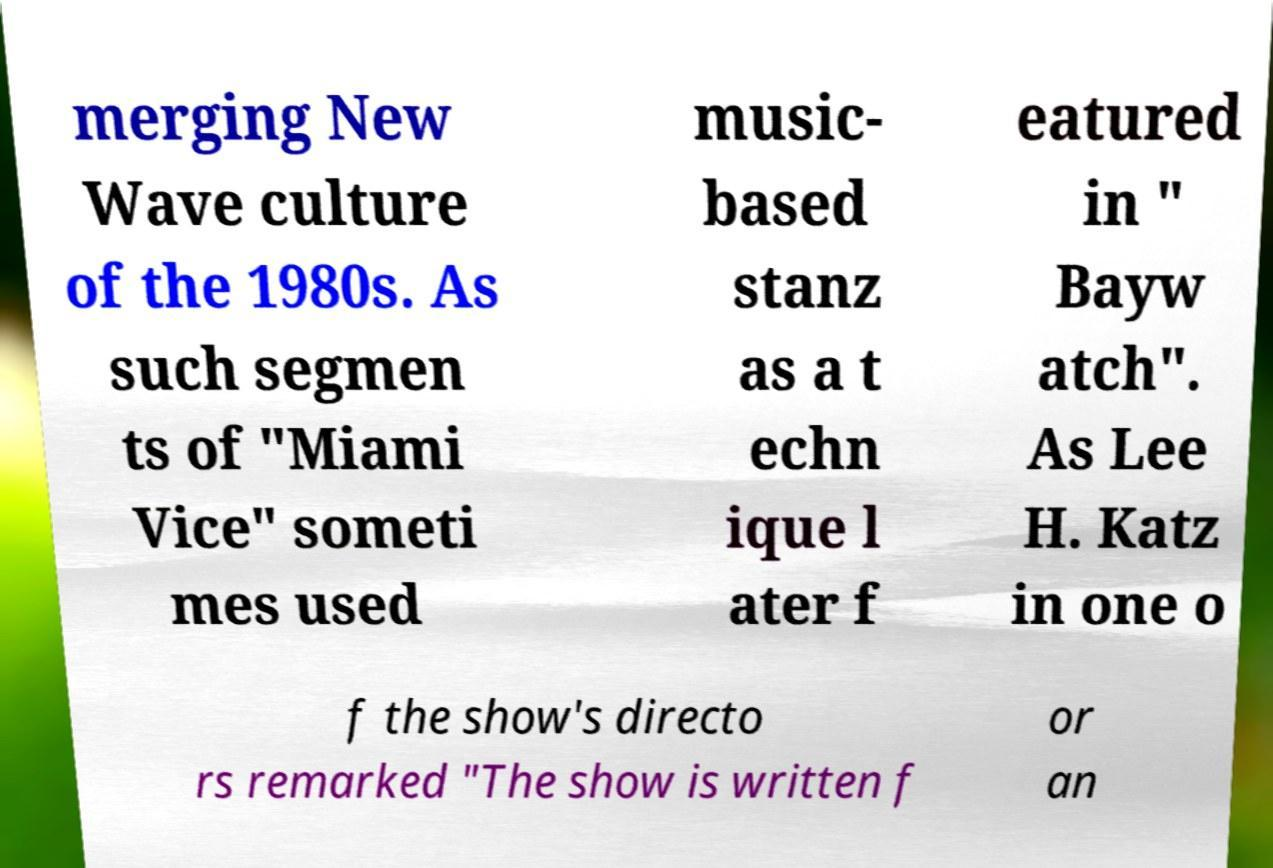Can you accurately transcribe the text from the provided image for me? merging New Wave culture of the 1980s. As such segmen ts of "Miami Vice" someti mes used music- based stanz as a t echn ique l ater f eatured in " Bayw atch". As Lee H. Katz in one o f the show's directo rs remarked "The show is written f or an 